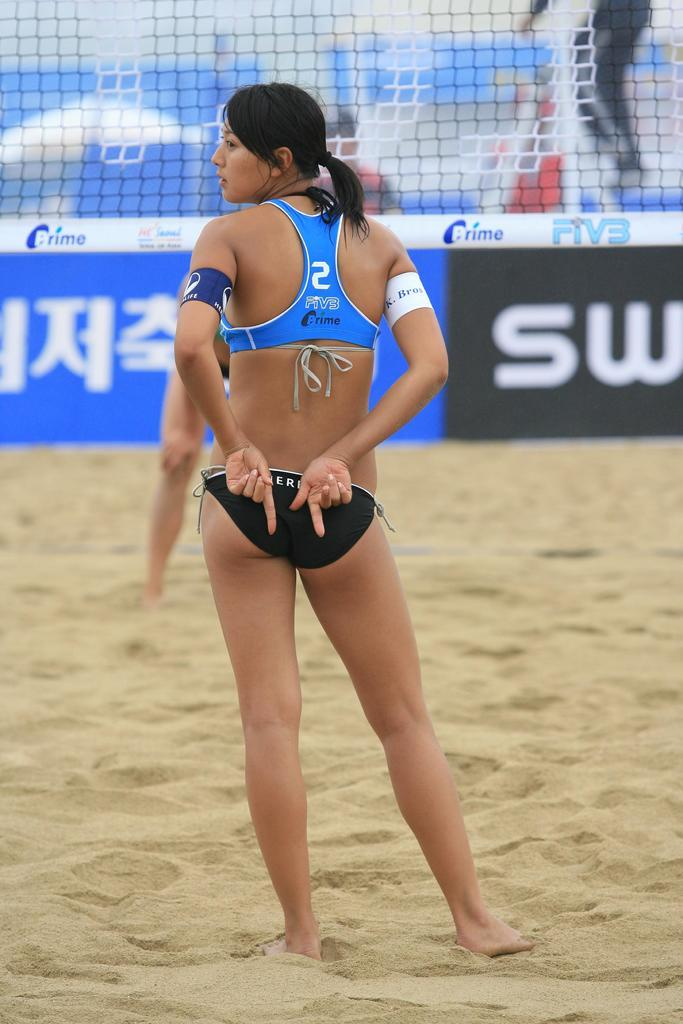<image>
Relay a brief, clear account of the picture shown. a female volleyball player number 2 waiting in front of a net 